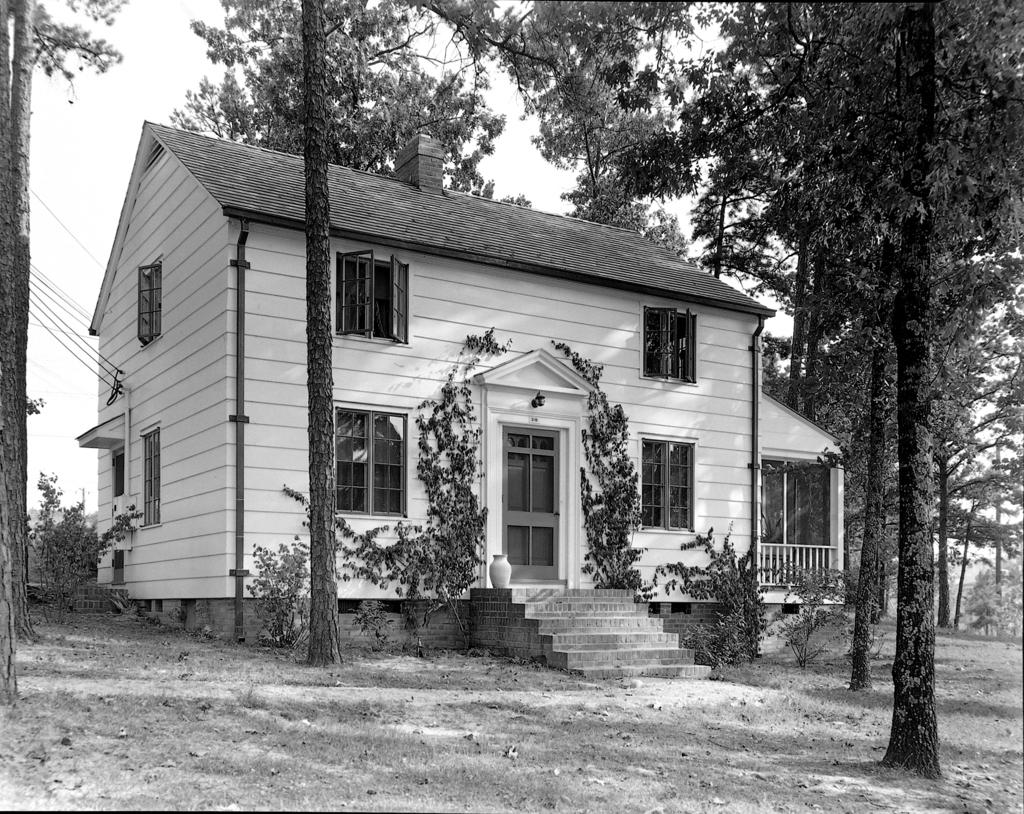What type of structure is present in the image? There is a building in the picture. What features can be seen on the building? The building has a door, windows, and stairs. What else is visible in the image besides the building? There are trees in the picture. How would you describe the weather based on the image? The sky is clear in the image, suggesting good weather. Can you see any cracks in the building's walls in the image? There is no mention of cracks in the building's walls in the provided facts, so we cannot determine their presence from the image. 